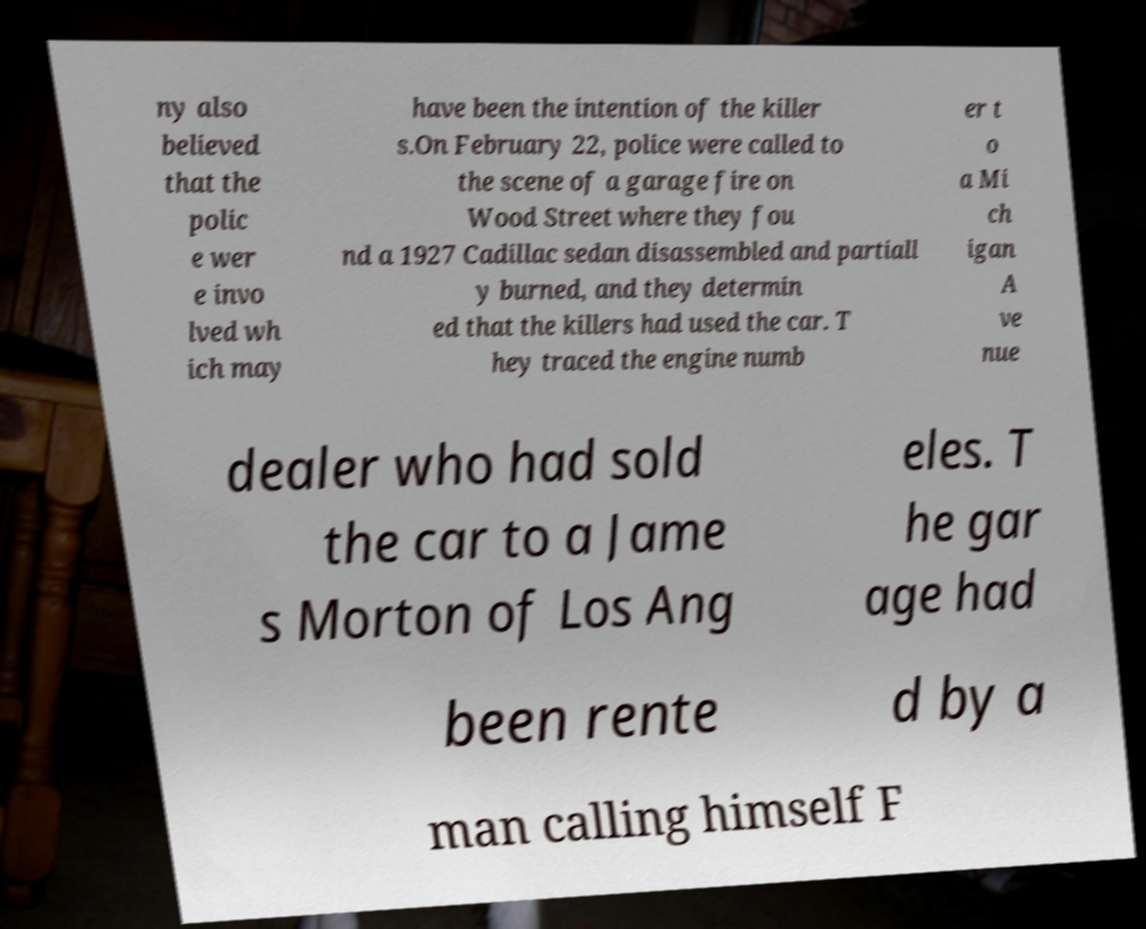For documentation purposes, I need the text within this image transcribed. Could you provide that? ny also believed that the polic e wer e invo lved wh ich may have been the intention of the killer s.On February 22, police were called to the scene of a garage fire on Wood Street where they fou nd a 1927 Cadillac sedan disassembled and partiall y burned, and they determin ed that the killers had used the car. T hey traced the engine numb er t o a Mi ch igan A ve nue dealer who had sold the car to a Jame s Morton of Los Ang eles. T he gar age had been rente d by a man calling himself F 